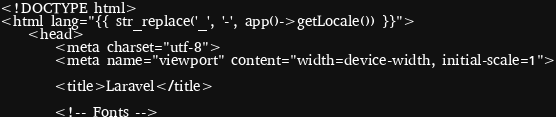Convert code to text. <code><loc_0><loc_0><loc_500><loc_500><_PHP_><!DOCTYPE html>
<html lang="{{ str_replace('_', '-', app()->getLocale()) }}">
    <head>
        <meta charset="utf-8">
        <meta name="viewport" content="width=device-width, initial-scale=1">

        <title>Laravel</title>

        <!-- Fonts --></code> 